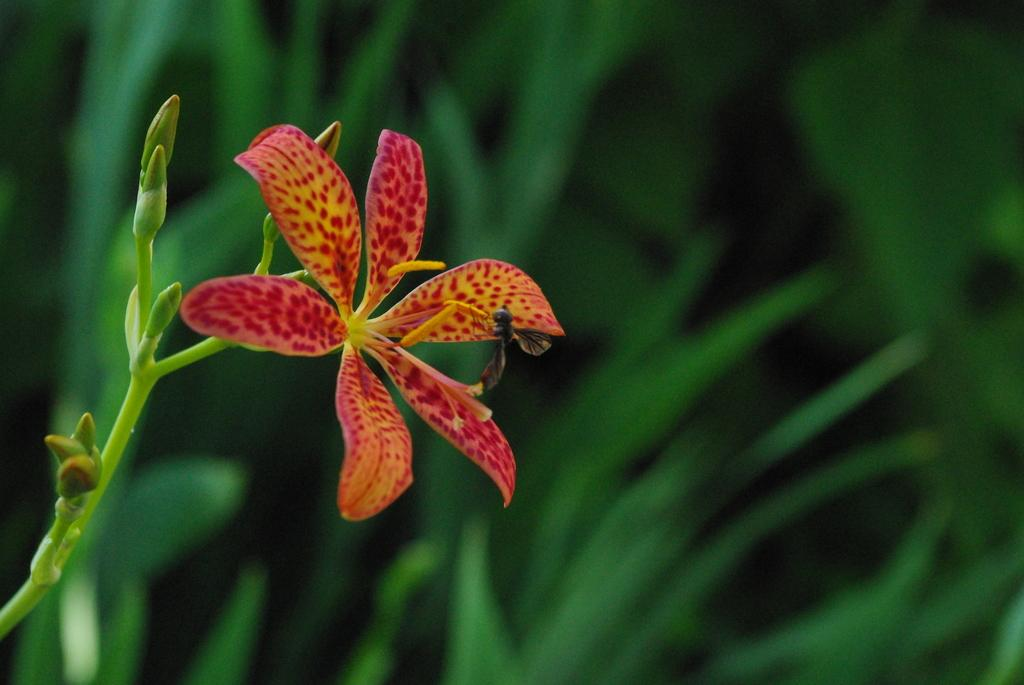What type of living organisms can be seen in the image? Plants can be seen in the image. What specific features can be observed on the plants? The plants have flowers, and the flowers have buds. Are there any other living organisms present in the image? Yes, there is an insect on one of the flowers. What type of haircut does the plant have in the image? Plants do not have haircuts, as they are not human or animals. 